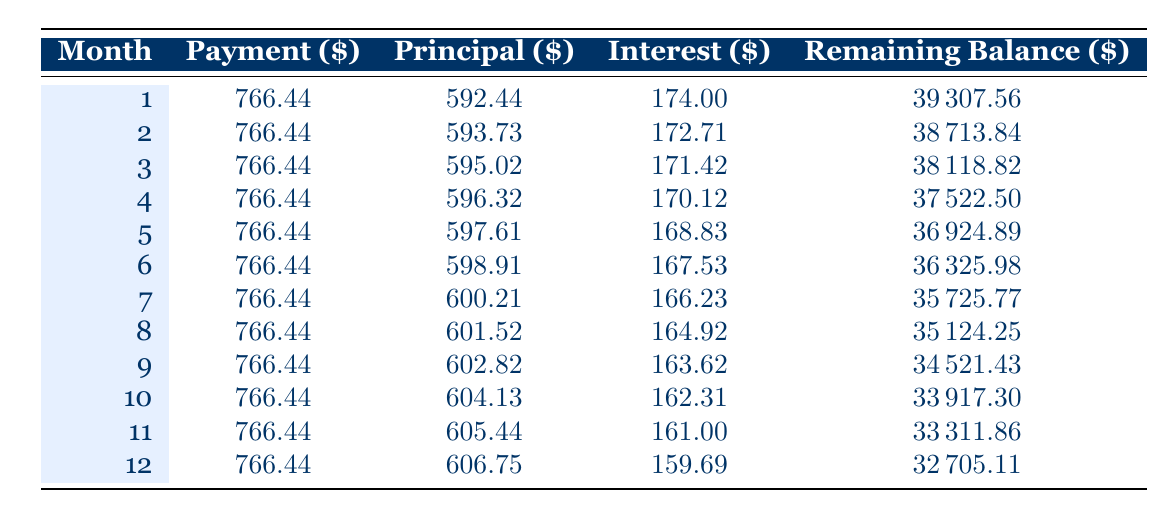What is the total payment for the first month? The payment for the first month is listed in the table under the "Payment" column for month 1. It is 766.44.
Answer: 766.44 What is the principal portion of the payment in the second month? The principal portion for the second month is given in the "Principal" column for month 2. It is 593.73.
Answer: 593.73 How much interest is paid in the third month? The interest paid in the third month is found in the "Interest" column for month 3. It is 171.42.
Answer: 171.42 What is the average monthly payment over the first three months? The monthly payment is constant at 766.44 for each month. The average is therefore simply that value: 766.44.
Answer: 766.44 Is the remaining balance after the fourth month lower than 37,000? The remaining balance after the fourth month is 37522.50. Since this is greater than 37,000, the answer is no.
Answer: No What is the total interest paid from the first to the sixth month? The total interest paid from the first to the sixth month is the sum of the interest values for months 1 through 6: 174.00 + 172.71 + 171.42 + 170.12 + 168.83 + 167.53 = 1024.61.
Answer: 1024.61 In which month does the principal payment exceed 600? Looking at the "Principal" column, the principal exceeds 600 starting in month 7 when it is 600.21.
Answer: Month 7 What is the remaining balance after making payments for the first 12 months? The remaining balance after the 12th month is written in the "Remaining Balance" column for month 12, which is 32705.11.
Answer: 32705.11 Is the interest payment in the first month higher than in the second month? The interest payment for month 1 is 174.00 and for month 2 is 172.71. Since 174.00 is greater than 172.71, the answer is yes.
Answer: Yes 